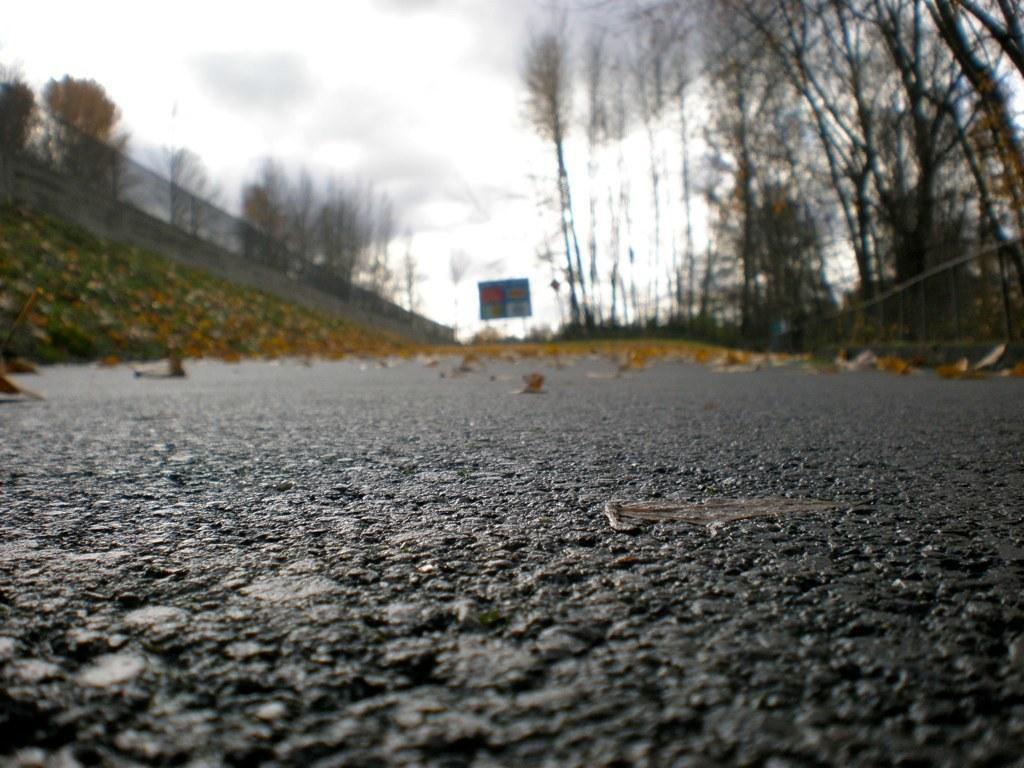Could you give a brief overview of what you see in this image? In this picture there is a black color tar road with banner. Behind we can see the boundary wall with fencing grill. On the right side there are some dry trees. 